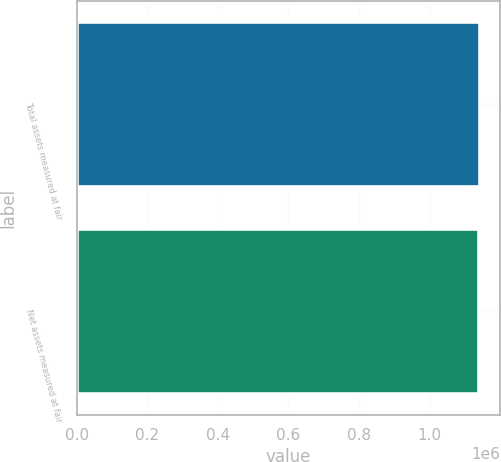Convert chart to OTSL. <chart><loc_0><loc_0><loc_500><loc_500><bar_chart><fcel>Total assets measured at fair<fcel>Net assets measured at fair<nl><fcel>1.14216e+06<fcel>1.14108e+06<nl></chart> 